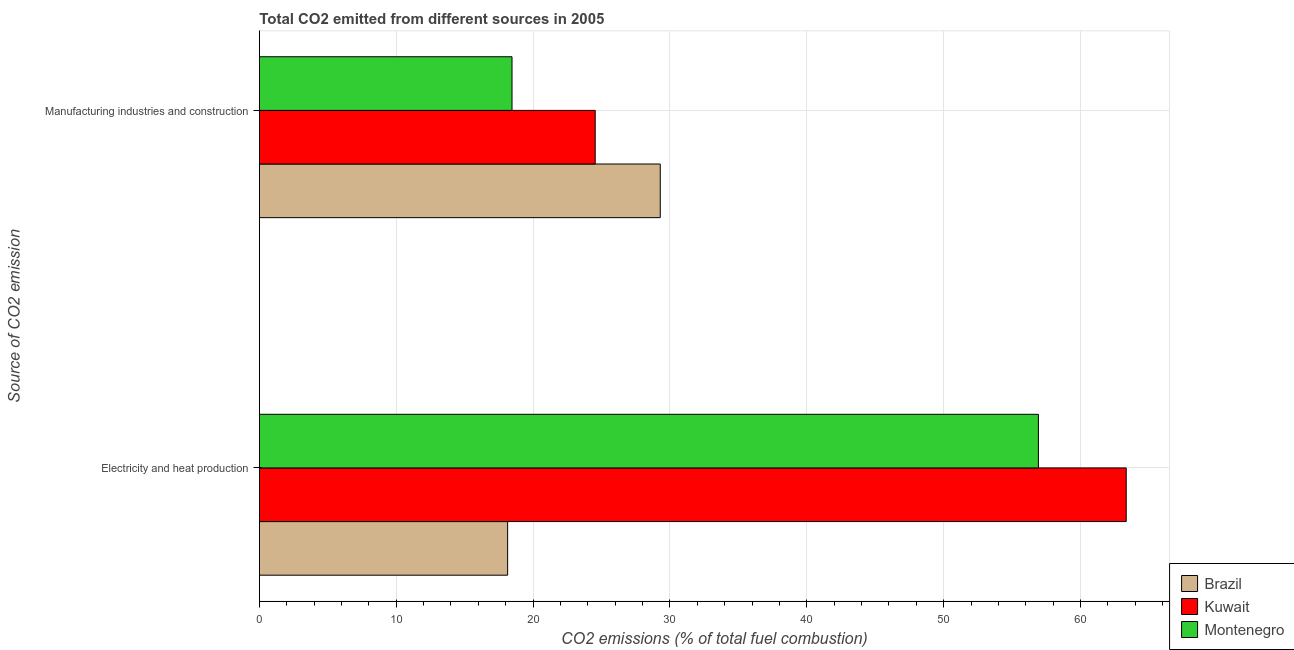How many different coloured bars are there?
Offer a terse response. 3. Are the number of bars on each tick of the Y-axis equal?
Give a very brief answer. Yes. How many bars are there on the 2nd tick from the top?
Provide a succinct answer. 3. What is the label of the 2nd group of bars from the top?
Offer a terse response. Electricity and heat production. What is the co2 emissions due to electricity and heat production in Brazil?
Give a very brief answer. 18.14. Across all countries, what is the maximum co2 emissions due to manufacturing industries?
Ensure brevity in your answer.  29.29. Across all countries, what is the minimum co2 emissions due to manufacturing industries?
Provide a succinct answer. 18.46. What is the total co2 emissions due to manufacturing industries in the graph?
Offer a very short reply. 72.29. What is the difference between the co2 emissions due to manufacturing industries in Brazil and that in Montenegro?
Your response must be concise. 10.83. What is the difference between the co2 emissions due to electricity and heat production in Montenegro and the co2 emissions due to manufacturing industries in Kuwait?
Make the answer very short. 32.38. What is the average co2 emissions due to manufacturing industries per country?
Your response must be concise. 24.1. What is the difference between the co2 emissions due to electricity and heat production and co2 emissions due to manufacturing industries in Brazil?
Your answer should be compact. -11.15. In how many countries, is the co2 emissions due to electricity and heat production greater than 8 %?
Your response must be concise. 3. What is the ratio of the co2 emissions due to manufacturing industries in Kuwait to that in Montenegro?
Ensure brevity in your answer.  1.33. In how many countries, is the co2 emissions due to manufacturing industries greater than the average co2 emissions due to manufacturing industries taken over all countries?
Provide a short and direct response. 2. What does the 2nd bar from the top in Manufacturing industries and construction represents?
Your response must be concise. Kuwait. What does the 3rd bar from the bottom in Electricity and heat production represents?
Your answer should be very brief. Montenegro. How many bars are there?
Provide a succinct answer. 6. Are all the bars in the graph horizontal?
Give a very brief answer. Yes. How many countries are there in the graph?
Offer a terse response. 3. What is the difference between two consecutive major ticks on the X-axis?
Offer a terse response. 10. Are the values on the major ticks of X-axis written in scientific E-notation?
Offer a terse response. No. Does the graph contain grids?
Keep it short and to the point. Yes. How are the legend labels stacked?
Ensure brevity in your answer.  Vertical. What is the title of the graph?
Offer a terse response. Total CO2 emitted from different sources in 2005. Does "Middle income" appear as one of the legend labels in the graph?
Offer a very short reply. No. What is the label or title of the X-axis?
Your response must be concise. CO2 emissions (% of total fuel combustion). What is the label or title of the Y-axis?
Your answer should be compact. Source of CO2 emission. What is the CO2 emissions (% of total fuel combustion) of Brazil in Electricity and heat production?
Your answer should be compact. 18.14. What is the CO2 emissions (% of total fuel combustion) in Kuwait in Electricity and heat production?
Provide a short and direct response. 63.34. What is the CO2 emissions (% of total fuel combustion) in Montenegro in Electricity and heat production?
Your answer should be very brief. 56.92. What is the CO2 emissions (% of total fuel combustion) in Brazil in Manufacturing industries and construction?
Keep it short and to the point. 29.29. What is the CO2 emissions (% of total fuel combustion) in Kuwait in Manufacturing industries and construction?
Your answer should be compact. 24.54. What is the CO2 emissions (% of total fuel combustion) in Montenegro in Manufacturing industries and construction?
Your response must be concise. 18.46. Across all Source of CO2 emission, what is the maximum CO2 emissions (% of total fuel combustion) in Brazil?
Provide a short and direct response. 29.29. Across all Source of CO2 emission, what is the maximum CO2 emissions (% of total fuel combustion) in Kuwait?
Your response must be concise. 63.34. Across all Source of CO2 emission, what is the maximum CO2 emissions (% of total fuel combustion) of Montenegro?
Make the answer very short. 56.92. Across all Source of CO2 emission, what is the minimum CO2 emissions (% of total fuel combustion) in Brazil?
Your answer should be very brief. 18.14. Across all Source of CO2 emission, what is the minimum CO2 emissions (% of total fuel combustion) in Kuwait?
Offer a terse response. 24.54. Across all Source of CO2 emission, what is the minimum CO2 emissions (% of total fuel combustion) of Montenegro?
Your answer should be very brief. 18.46. What is the total CO2 emissions (% of total fuel combustion) in Brazil in the graph?
Offer a very short reply. 47.43. What is the total CO2 emissions (% of total fuel combustion) of Kuwait in the graph?
Provide a short and direct response. 87.88. What is the total CO2 emissions (% of total fuel combustion) of Montenegro in the graph?
Offer a terse response. 75.38. What is the difference between the CO2 emissions (% of total fuel combustion) of Brazil in Electricity and heat production and that in Manufacturing industries and construction?
Keep it short and to the point. -11.15. What is the difference between the CO2 emissions (% of total fuel combustion) in Kuwait in Electricity and heat production and that in Manufacturing industries and construction?
Offer a very short reply. 38.8. What is the difference between the CO2 emissions (% of total fuel combustion) of Montenegro in Electricity and heat production and that in Manufacturing industries and construction?
Give a very brief answer. 38.46. What is the difference between the CO2 emissions (% of total fuel combustion) in Brazil in Electricity and heat production and the CO2 emissions (% of total fuel combustion) in Kuwait in Manufacturing industries and construction?
Your answer should be very brief. -6.4. What is the difference between the CO2 emissions (% of total fuel combustion) in Brazil in Electricity and heat production and the CO2 emissions (% of total fuel combustion) in Montenegro in Manufacturing industries and construction?
Make the answer very short. -0.32. What is the difference between the CO2 emissions (% of total fuel combustion) in Kuwait in Electricity and heat production and the CO2 emissions (% of total fuel combustion) in Montenegro in Manufacturing industries and construction?
Your answer should be very brief. 44.88. What is the average CO2 emissions (% of total fuel combustion) in Brazil per Source of CO2 emission?
Ensure brevity in your answer.  23.72. What is the average CO2 emissions (% of total fuel combustion) in Kuwait per Source of CO2 emission?
Provide a succinct answer. 43.94. What is the average CO2 emissions (% of total fuel combustion) in Montenegro per Source of CO2 emission?
Provide a succinct answer. 37.69. What is the difference between the CO2 emissions (% of total fuel combustion) in Brazil and CO2 emissions (% of total fuel combustion) in Kuwait in Electricity and heat production?
Keep it short and to the point. -45.2. What is the difference between the CO2 emissions (% of total fuel combustion) in Brazil and CO2 emissions (% of total fuel combustion) in Montenegro in Electricity and heat production?
Your answer should be very brief. -38.78. What is the difference between the CO2 emissions (% of total fuel combustion) in Kuwait and CO2 emissions (% of total fuel combustion) in Montenegro in Electricity and heat production?
Your answer should be very brief. 6.42. What is the difference between the CO2 emissions (% of total fuel combustion) of Brazil and CO2 emissions (% of total fuel combustion) of Kuwait in Manufacturing industries and construction?
Offer a terse response. 4.75. What is the difference between the CO2 emissions (% of total fuel combustion) of Brazil and CO2 emissions (% of total fuel combustion) of Montenegro in Manufacturing industries and construction?
Offer a very short reply. 10.83. What is the difference between the CO2 emissions (% of total fuel combustion) of Kuwait and CO2 emissions (% of total fuel combustion) of Montenegro in Manufacturing industries and construction?
Ensure brevity in your answer.  6.08. What is the ratio of the CO2 emissions (% of total fuel combustion) of Brazil in Electricity and heat production to that in Manufacturing industries and construction?
Your answer should be compact. 0.62. What is the ratio of the CO2 emissions (% of total fuel combustion) in Kuwait in Electricity and heat production to that in Manufacturing industries and construction?
Provide a short and direct response. 2.58. What is the ratio of the CO2 emissions (% of total fuel combustion) in Montenegro in Electricity and heat production to that in Manufacturing industries and construction?
Ensure brevity in your answer.  3.08. What is the difference between the highest and the second highest CO2 emissions (% of total fuel combustion) in Brazil?
Provide a succinct answer. 11.15. What is the difference between the highest and the second highest CO2 emissions (% of total fuel combustion) of Kuwait?
Provide a short and direct response. 38.8. What is the difference between the highest and the second highest CO2 emissions (% of total fuel combustion) in Montenegro?
Your response must be concise. 38.46. What is the difference between the highest and the lowest CO2 emissions (% of total fuel combustion) of Brazil?
Make the answer very short. 11.15. What is the difference between the highest and the lowest CO2 emissions (% of total fuel combustion) in Kuwait?
Your response must be concise. 38.8. What is the difference between the highest and the lowest CO2 emissions (% of total fuel combustion) of Montenegro?
Offer a very short reply. 38.46. 